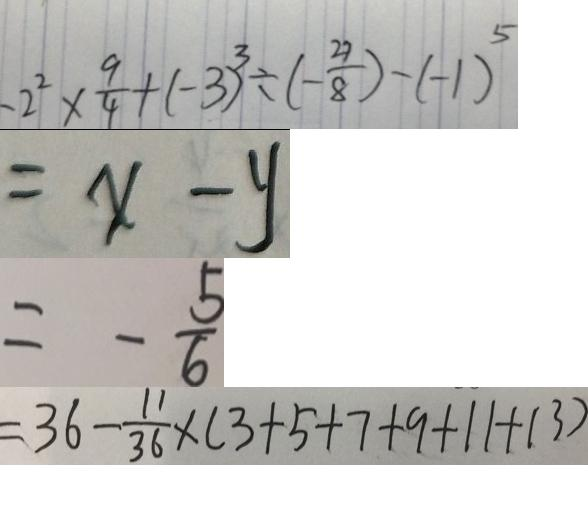Convert formula to latex. <formula><loc_0><loc_0><loc_500><loc_500>- 2 ^ { 2 } \times \frac { 9 } { 4 } + ( - 3 ) ^ { 3 } \div ( - \frac { 2 7 } { 8 } ) - ( - 1 ) ^ { 5 } 
 = x - y 
 = - \frac { 5 } { 6 } 
 = 3 6 - \frac { 1 1 } { 3 6 } \times ( 3 + 5 + 7 + 9 + 1 1 + 1 3 )</formula> 